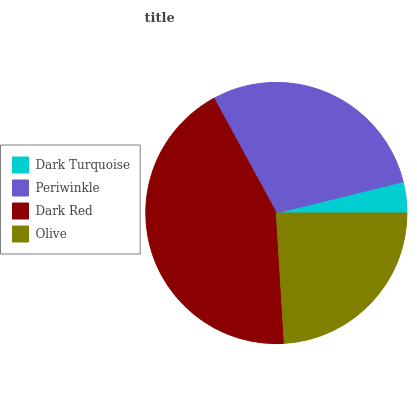Is Dark Turquoise the minimum?
Answer yes or no. Yes. Is Dark Red the maximum?
Answer yes or no. Yes. Is Periwinkle the minimum?
Answer yes or no. No. Is Periwinkle the maximum?
Answer yes or no. No. Is Periwinkle greater than Dark Turquoise?
Answer yes or no. Yes. Is Dark Turquoise less than Periwinkle?
Answer yes or no. Yes. Is Dark Turquoise greater than Periwinkle?
Answer yes or no. No. Is Periwinkle less than Dark Turquoise?
Answer yes or no. No. Is Periwinkle the high median?
Answer yes or no. Yes. Is Olive the low median?
Answer yes or no. Yes. Is Dark Red the high median?
Answer yes or no. No. Is Dark Turquoise the low median?
Answer yes or no. No. 